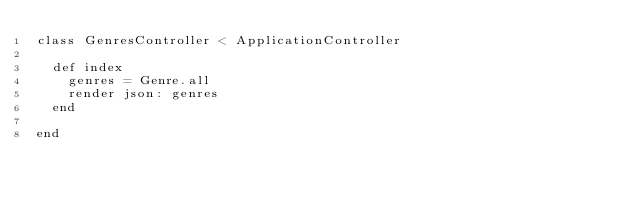<code> <loc_0><loc_0><loc_500><loc_500><_Ruby_>class GenresController < ApplicationController

  def index
    genres = Genre.all
    render json: genres
  end

end
</code> 